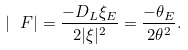Convert formula to latex. <formula><loc_0><loc_0><loc_500><loc_500>| \ F | = \frac { - D _ { L } \xi _ { E } } { 2 | \xi | ^ { 2 } } = \frac { - \theta _ { E } } { 2 \theta ^ { 2 } } .</formula> 